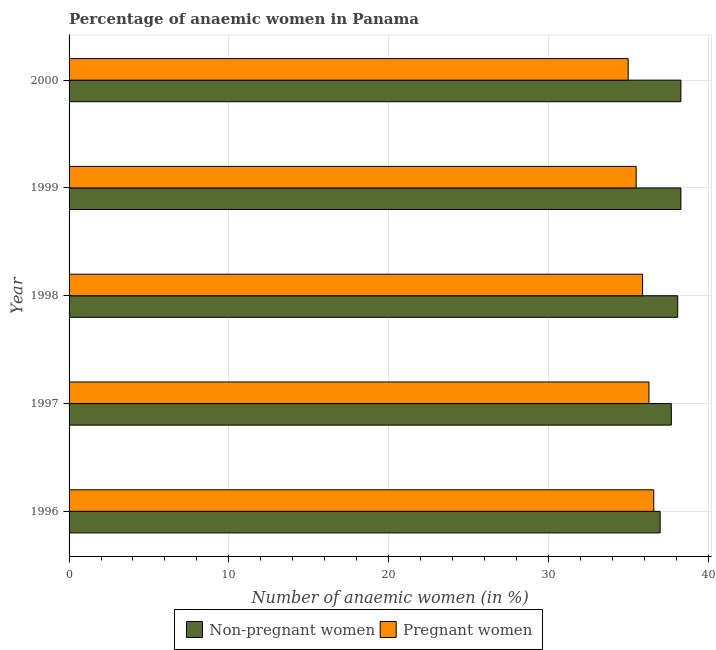How many groups of bars are there?
Ensure brevity in your answer.  5. How many bars are there on the 3rd tick from the top?
Ensure brevity in your answer.  2. What is the label of the 4th group of bars from the top?
Your answer should be very brief. 1997. What is the percentage of non-pregnant anaemic women in 1999?
Give a very brief answer. 38.3. Across all years, what is the maximum percentage of pregnant anaemic women?
Provide a succinct answer. 36.6. Across all years, what is the minimum percentage of non-pregnant anaemic women?
Your answer should be very brief. 37. In which year was the percentage of pregnant anaemic women minimum?
Provide a short and direct response. 2000. What is the total percentage of pregnant anaemic women in the graph?
Offer a very short reply. 179.3. What is the difference between the percentage of pregnant anaemic women in 1997 and the percentage of non-pregnant anaemic women in 2000?
Offer a terse response. -2. What is the average percentage of non-pregnant anaemic women per year?
Your answer should be very brief. 37.88. In how many years, is the percentage of pregnant anaemic women greater than 30 %?
Provide a succinct answer. 5. What is the ratio of the percentage of non-pregnant anaemic women in 1997 to that in 1998?
Provide a short and direct response. 0.99. What is the difference between the highest and the lowest percentage of pregnant anaemic women?
Keep it short and to the point. 1.6. In how many years, is the percentage of pregnant anaemic women greater than the average percentage of pregnant anaemic women taken over all years?
Your answer should be very brief. 3. What does the 1st bar from the top in 1999 represents?
Your response must be concise. Pregnant women. What does the 2nd bar from the bottom in 1996 represents?
Give a very brief answer. Pregnant women. How many bars are there?
Give a very brief answer. 10. Are the values on the major ticks of X-axis written in scientific E-notation?
Ensure brevity in your answer.  No. Does the graph contain any zero values?
Make the answer very short. No. What is the title of the graph?
Ensure brevity in your answer.  Percentage of anaemic women in Panama. What is the label or title of the X-axis?
Offer a very short reply. Number of anaemic women (in %). What is the label or title of the Y-axis?
Provide a short and direct response. Year. What is the Number of anaemic women (in %) in Non-pregnant women in 1996?
Ensure brevity in your answer.  37. What is the Number of anaemic women (in %) in Pregnant women in 1996?
Your answer should be very brief. 36.6. What is the Number of anaemic women (in %) of Non-pregnant women in 1997?
Offer a very short reply. 37.7. What is the Number of anaemic women (in %) in Pregnant women in 1997?
Make the answer very short. 36.3. What is the Number of anaemic women (in %) in Non-pregnant women in 1998?
Offer a terse response. 38.1. What is the Number of anaemic women (in %) in Pregnant women in 1998?
Keep it short and to the point. 35.9. What is the Number of anaemic women (in %) of Non-pregnant women in 1999?
Your answer should be compact. 38.3. What is the Number of anaemic women (in %) of Pregnant women in 1999?
Provide a short and direct response. 35.5. What is the Number of anaemic women (in %) of Non-pregnant women in 2000?
Your answer should be compact. 38.3. Across all years, what is the maximum Number of anaemic women (in %) in Non-pregnant women?
Keep it short and to the point. 38.3. Across all years, what is the maximum Number of anaemic women (in %) of Pregnant women?
Give a very brief answer. 36.6. What is the total Number of anaemic women (in %) of Non-pregnant women in the graph?
Offer a very short reply. 189.4. What is the total Number of anaemic women (in %) in Pregnant women in the graph?
Provide a short and direct response. 179.3. What is the difference between the Number of anaemic women (in %) of Pregnant women in 1996 and that in 1997?
Ensure brevity in your answer.  0.3. What is the difference between the Number of anaemic women (in %) of Non-pregnant women in 1996 and that in 1999?
Make the answer very short. -1.3. What is the difference between the Number of anaemic women (in %) of Pregnant women in 1996 and that in 2000?
Ensure brevity in your answer.  1.6. What is the difference between the Number of anaemic women (in %) in Pregnant women in 1997 and that in 1998?
Keep it short and to the point. 0.4. What is the difference between the Number of anaemic women (in %) in Non-pregnant women in 1997 and that in 2000?
Provide a succinct answer. -0.6. What is the difference between the Number of anaemic women (in %) in Pregnant women in 1997 and that in 2000?
Your answer should be compact. 1.3. What is the difference between the Number of anaemic women (in %) of Pregnant women in 1999 and that in 2000?
Make the answer very short. 0.5. What is the difference between the Number of anaemic women (in %) in Non-pregnant women in 1996 and the Number of anaemic women (in %) in Pregnant women in 1998?
Make the answer very short. 1.1. What is the difference between the Number of anaemic women (in %) of Non-pregnant women in 1996 and the Number of anaemic women (in %) of Pregnant women in 1999?
Provide a succinct answer. 1.5. What is the difference between the Number of anaemic women (in %) of Non-pregnant women in 1996 and the Number of anaemic women (in %) of Pregnant women in 2000?
Offer a terse response. 2. What is the difference between the Number of anaemic women (in %) of Non-pregnant women in 1997 and the Number of anaemic women (in %) of Pregnant women in 1999?
Ensure brevity in your answer.  2.2. What is the difference between the Number of anaemic women (in %) in Non-pregnant women in 1997 and the Number of anaemic women (in %) in Pregnant women in 2000?
Make the answer very short. 2.7. What is the difference between the Number of anaemic women (in %) of Non-pregnant women in 1998 and the Number of anaemic women (in %) of Pregnant women in 1999?
Your answer should be very brief. 2.6. What is the difference between the Number of anaemic women (in %) in Non-pregnant women in 1999 and the Number of anaemic women (in %) in Pregnant women in 2000?
Your answer should be compact. 3.3. What is the average Number of anaemic women (in %) in Non-pregnant women per year?
Provide a succinct answer. 37.88. What is the average Number of anaemic women (in %) of Pregnant women per year?
Your response must be concise. 35.86. In the year 1998, what is the difference between the Number of anaemic women (in %) of Non-pregnant women and Number of anaemic women (in %) of Pregnant women?
Your response must be concise. 2.2. In the year 1999, what is the difference between the Number of anaemic women (in %) of Non-pregnant women and Number of anaemic women (in %) of Pregnant women?
Make the answer very short. 2.8. What is the ratio of the Number of anaemic women (in %) of Non-pregnant women in 1996 to that in 1997?
Make the answer very short. 0.98. What is the ratio of the Number of anaemic women (in %) in Pregnant women in 1996 to that in 1997?
Your answer should be compact. 1.01. What is the ratio of the Number of anaemic women (in %) of Non-pregnant women in 1996 to that in 1998?
Ensure brevity in your answer.  0.97. What is the ratio of the Number of anaemic women (in %) of Pregnant women in 1996 to that in 1998?
Give a very brief answer. 1.02. What is the ratio of the Number of anaemic women (in %) in Non-pregnant women in 1996 to that in 1999?
Offer a very short reply. 0.97. What is the ratio of the Number of anaemic women (in %) in Pregnant women in 1996 to that in 1999?
Keep it short and to the point. 1.03. What is the ratio of the Number of anaemic women (in %) in Non-pregnant women in 1996 to that in 2000?
Provide a short and direct response. 0.97. What is the ratio of the Number of anaemic women (in %) in Pregnant women in 1996 to that in 2000?
Give a very brief answer. 1.05. What is the ratio of the Number of anaemic women (in %) in Pregnant women in 1997 to that in 1998?
Your answer should be very brief. 1.01. What is the ratio of the Number of anaemic women (in %) of Non-pregnant women in 1997 to that in 1999?
Give a very brief answer. 0.98. What is the ratio of the Number of anaemic women (in %) of Pregnant women in 1997 to that in 1999?
Your answer should be compact. 1.02. What is the ratio of the Number of anaemic women (in %) of Non-pregnant women in 1997 to that in 2000?
Offer a terse response. 0.98. What is the ratio of the Number of anaemic women (in %) of Pregnant women in 1997 to that in 2000?
Give a very brief answer. 1.04. What is the ratio of the Number of anaemic women (in %) of Pregnant women in 1998 to that in 1999?
Offer a terse response. 1.01. What is the ratio of the Number of anaemic women (in %) of Non-pregnant women in 1998 to that in 2000?
Keep it short and to the point. 0.99. What is the ratio of the Number of anaemic women (in %) of Pregnant women in 1998 to that in 2000?
Keep it short and to the point. 1.03. What is the ratio of the Number of anaemic women (in %) of Pregnant women in 1999 to that in 2000?
Your response must be concise. 1.01. What is the difference between the highest and the second highest Number of anaemic women (in %) of Pregnant women?
Offer a terse response. 0.3. What is the difference between the highest and the lowest Number of anaemic women (in %) in Pregnant women?
Make the answer very short. 1.6. 